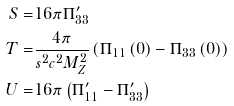Convert formula to latex. <formula><loc_0><loc_0><loc_500><loc_500>S = & 1 6 \pi \Pi _ { 3 3 } ^ { \prime } \\ T = & \frac { 4 \pi } { s ^ { 2 } c ^ { 2 } M _ { Z } ^ { 2 } } \left ( \Pi _ { 1 1 } \left ( 0 \right ) - \Pi _ { 3 3 } \left ( 0 \right ) \right ) \\ U = & 1 6 \pi \left ( \Pi _ { 1 1 } ^ { \prime } - \Pi _ { 3 3 } ^ { \prime } \right ) \\</formula> 